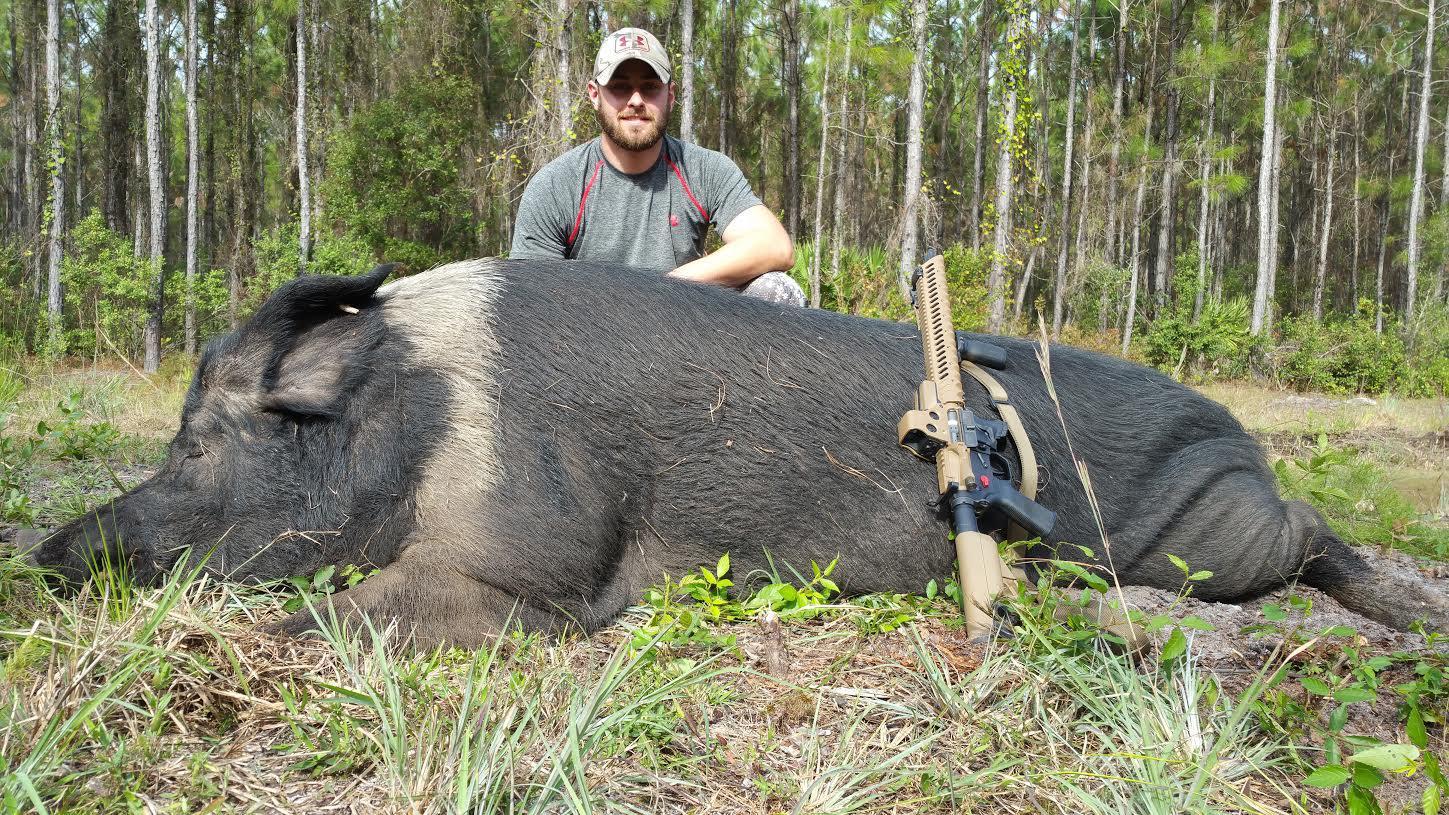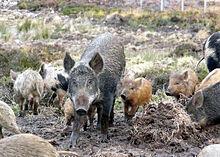The first image is the image on the left, the second image is the image on the right. Examine the images to the left and right. Is the description "A man with a gun poses behind a downed boar in the right image." accurate? Answer yes or no. No. The first image is the image on the left, the second image is the image on the right. Evaluate the accuracy of this statement regarding the images: "A single person is posing with a dead pig in the image on the left.". Is it true? Answer yes or no. Yes. 